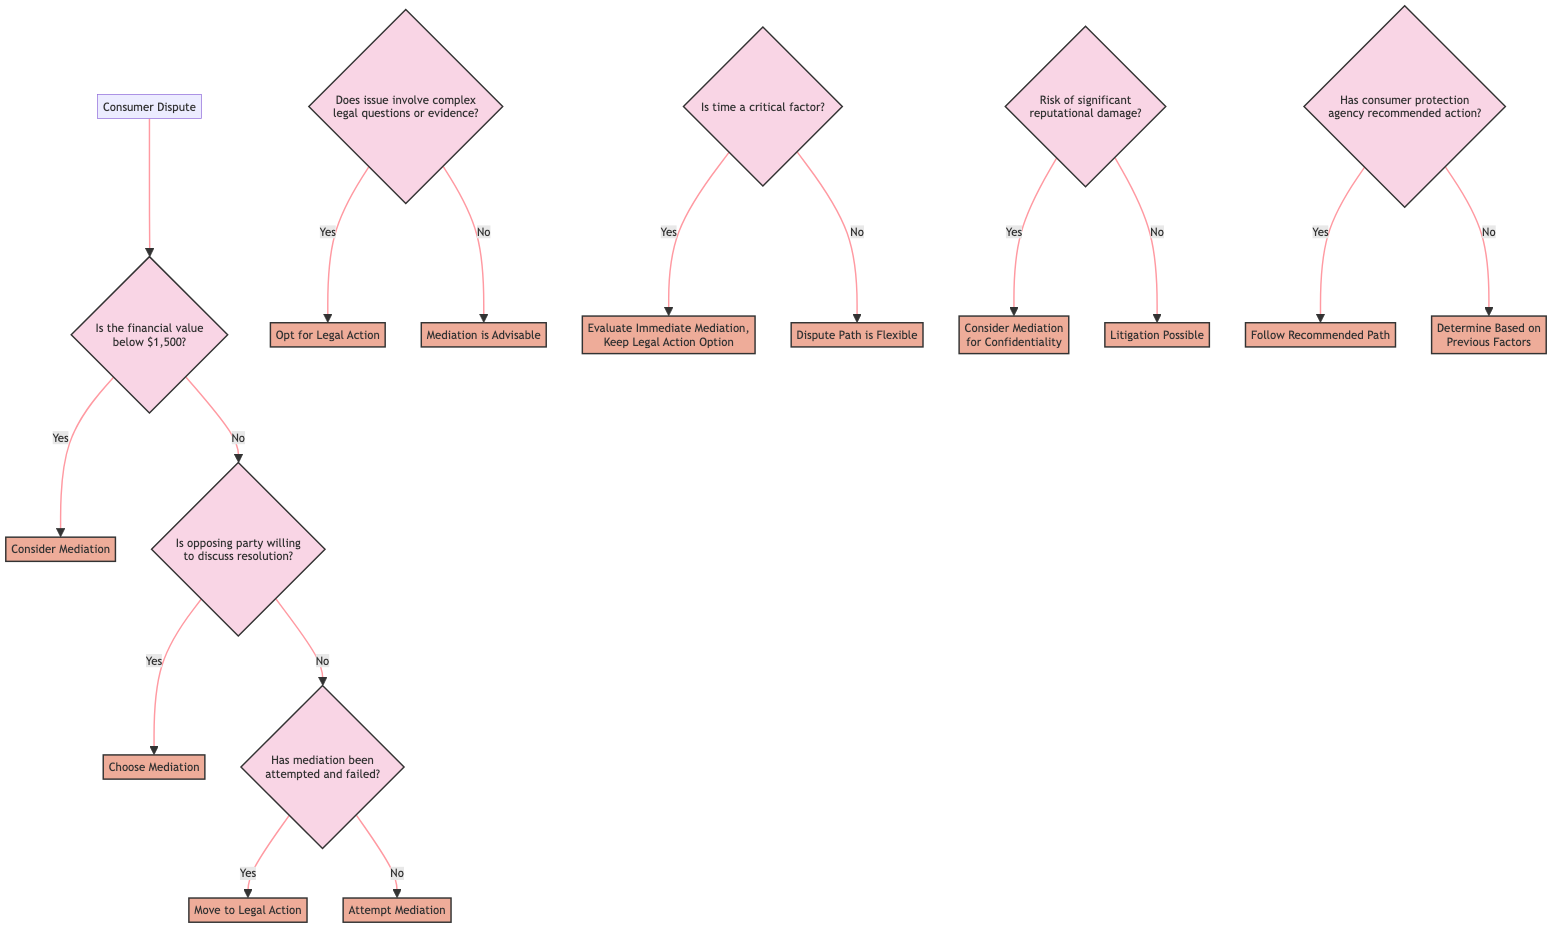What is the starting point of the decision tree? The starting point of the decision tree is the "Consumer Dispute".
Answer: Consumer Dispute How many criteria questions are in the decision tree? There are a total of 7 criteria questions present in the decision tree.
Answer: 7 What is the outcome if the financial value of the dispute is below $1,500? If the financial value of the dispute is below $1,500, the outcome is to "Consider Mediation".
Answer: Consider Mediation What happens if the opposing party is willing to discuss a resolution? If the opposing party is willing to discuss a resolution, the next step is to "Choose Mediation".
Answer: Choose Mediation Does the diagram provide an option for immediate mediation? Yes, the diagram allows for evaluating immediate mediation, with the option to keep legal action open if time is a critical factor.
Answer: Evaluate Immediate Mediation, Keep Legal Action Option What is the final decision path if the consumer protection agency recommends a specific course of action? If the consumer protection agency recommends a specific course of action, the decision is to "Follow Recommended Path".
Answer: Follow Recommended Path What should be considered if there is a risk of significant reputational damage? If there is a risk of significant reputational damage, it is advisable to "Consider Mediation for Confidentiality".
Answer: Consider Mediation for Confidentiality What do you do if mediation has been attempted but failed to resolve the dispute? If mediation has been attempted but failed, the next step is to "Move to Legal Action".
Answer: Move to Legal Action Is litigation an option if there is no risk of reputational damage? Yes, litigation is possible if there is no risk of significant reputational damage.
Answer: Litigation Possible 